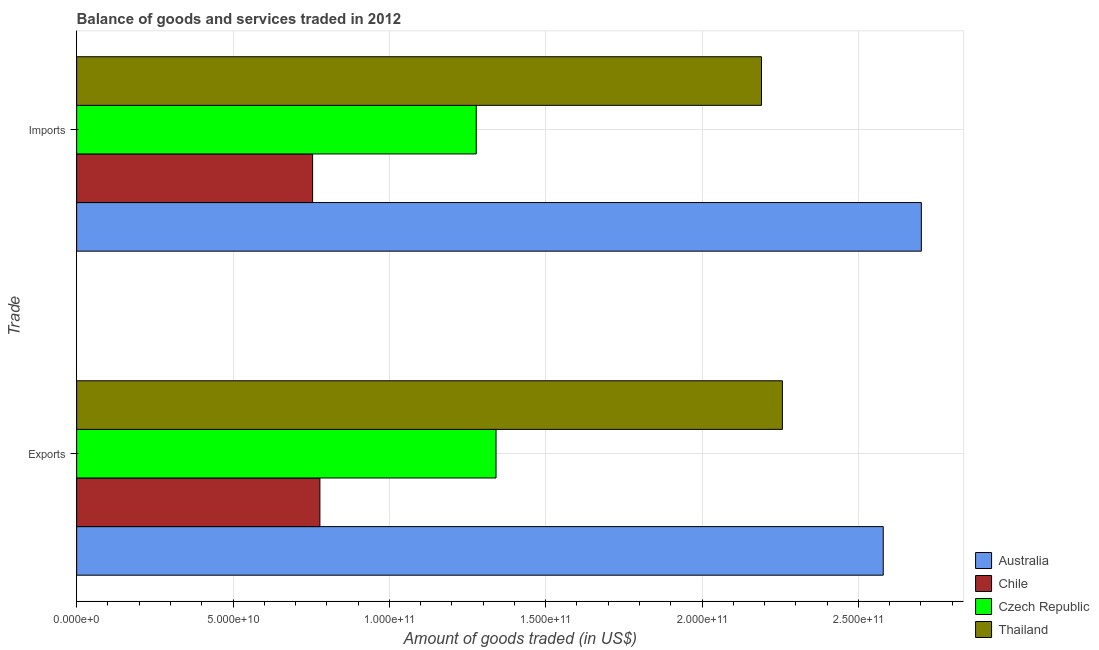How many different coloured bars are there?
Your answer should be compact. 4. How many groups of bars are there?
Offer a very short reply. 2. Are the number of bars on each tick of the Y-axis equal?
Offer a very short reply. Yes. What is the label of the 1st group of bars from the top?
Your answer should be very brief. Imports. What is the amount of goods exported in Chile?
Make the answer very short. 7.78e+1. Across all countries, what is the maximum amount of goods imported?
Your answer should be compact. 2.70e+11. Across all countries, what is the minimum amount of goods exported?
Keep it short and to the point. 7.78e+1. What is the total amount of goods exported in the graph?
Make the answer very short. 6.96e+11. What is the difference between the amount of goods exported in Australia and that in Thailand?
Your response must be concise. 3.22e+1. What is the difference between the amount of goods imported in Thailand and the amount of goods exported in Czech Republic?
Your answer should be compact. 8.49e+1. What is the average amount of goods exported per country?
Your answer should be very brief. 1.74e+11. What is the difference between the amount of goods exported and amount of goods imported in Czech Republic?
Your answer should be very brief. 6.34e+09. In how many countries, is the amount of goods exported greater than 270000000000 US$?
Make the answer very short. 0. What is the ratio of the amount of goods imported in Australia to that in Chile?
Your response must be concise. 3.58. In how many countries, is the amount of goods exported greater than the average amount of goods exported taken over all countries?
Make the answer very short. 2. What does the 4th bar from the top in Exports represents?
Offer a terse response. Australia. What does the 2nd bar from the bottom in Exports represents?
Give a very brief answer. Chile. How many bars are there?
Provide a short and direct response. 8. How many countries are there in the graph?
Offer a very short reply. 4. Does the graph contain any zero values?
Offer a terse response. No. Does the graph contain grids?
Offer a very short reply. Yes. Where does the legend appear in the graph?
Your answer should be compact. Bottom right. How many legend labels are there?
Provide a short and direct response. 4. What is the title of the graph?
Offer a very short reply. Balance of goods and services traded in 2012. What is the label or title of the X-axis?
Give a very brief answer. Amount of goods traded (in US$). What is the label or title of the Y-axis?
Offer a terse response. Trade. What is the Amount of goods traded (in US$) of Australia in Exports?
Your answer should be compact. 2.58e+11. What is the Amount of goods traded (in US$) of Chile in Exports?
Ensure brevity in your answer.  7.78e+1. What is the Amount of goods traded (in US$) in Czech Republic in Exports?
Make the answer very short. 1.34e+11. What is the Amount of goods traded (in US$) of Thailand in Exports?
Your response must be concise. 2.26e+11. What is the Amount of goods traded (in US$) in Australia in Imports?
Provide a short and direct response. 2.70e+11. What is the Amount of goods traded (in US$) in Chile in Imports?
Your response must be concise. 7.55e+1. What is the Amount of goods traded (in US$) of Czech Republic in Imports?
Give a very brief answer. 1.28e+11. What is the Amount of goods traded (in US$) in Thailand in Imports?
Keep it short and to the point. 2.19e+11. Across all Trade, what is the maximum Amount of goods traded (in US$) of Australia?
Give a very brief answer. 2.70e+11. Across all Trade, what is the maximum Amount of goods traded (in US$) in Chile?
Give a very brief answer. 7.78e+1. Across all Trade, what is the maximum Amount of goods traded (in US$) in Czech Republic?
Keep it short and to the point. 1.34e+11. Across all Trade, what is the maximum Amount of goods traded (in US$) of Thailand?
Keep it short and to the point. 2.26e+11. Across all Trade, what is the minimum Amount of goods traded (in US$) of Australia?
Your answer should be very brief. 2.58e+11. Across all Trade, what is the minimum Amount of goods traded (in US$) of Chile?
Make the answer very short. 7.55e+1. Across all Trade, what is the minimum Amount of goods traded (in US$) of Czech Republic?
Provide a succinct answer. 1.28e+11. Across all Trade, what is the minimum Amount of goods traded (in US$) in Thailand?
Your answer should be very brief. 2.19e+11. What is the total Amount of goods traded (in US$) of Australia in the graph?
Keep it short and to the point. 5.28e+11. What is the total Amount of goods traded (in US$) of Chile in the graph?
Offer a terse response. 1.53e+11. What is the total Amount of goods traded (in US$) in Czech Republic in the graph?
Provide a short and direct response. 2.62e+11. What is the total Amount of goods traded (in US$) of Thailand in the graph?
Your response must be concise. 4.45e+11. What is the difference between the Amount of goods traded (in US$) in Australia in Exports and that in Imports?
Offer a terse response. -1.22e+1. What is the difference between the Amount of goods traded (in US$) of Chile in Exports and that in Imports?
Your response must be concise. 2.33e+09. What is the difference between the Amount of goods traded (in US$) in Czech Republic in Exports and that in Imports?
Provide a short and direct response. 6.34e+09. What is the difference between the Amount of goods traded (in US$) of Thailand in Exports and that in Imports?
Offer a terse response. 6.69e+09. What is the difference between the Amount of goods traded (in US$) in Australia in Exports and the Amount of goods traded (in US$) in Chile in Imports?
Provide a succinct answer. 1.82e+11. What is the difference between the Amount of goods traded (in US$) in Australia in Exports and the Amount of goods traded (in US$) in Czech Republic in Imports?
Offer a terse response. 1.30e+11. What is the difference between the Amount of goods traded (in US$) of Australia in Exports and the Amount of goods traded (in US$) of Thailand in Imports?
Give a very brief answer. 3.89e+1. What is the difference between the Amount of goods traded (in US$) in Chile in Exports and the Amount of goods traded (in US$) in Czech Republic in Imports?
Ensure brevity in your answer.  -5.00e+1. What is the difference between the Amount of goods traded (in US$) in Chile in Exports and the Amount of goods traded (in US$) in Thailand in Imports?
Give a very brief answer. -1.41e+11. What is the difference between the Amount of goods traded (in US$) in Czech Republic in Exports and the Amount of goods traded (in US$) in Thailand in Imports?
Ensure brevity in your answer.  -8.49e+1. What is the average Amount of goods traded (in US$) in Australia per Trade?
Ensure brevity in your answer.  2.64e+11. What is the average Amount of goods traded (in US$) in Chile per Trade?
Your response must be concise. 7.66e+1. What is the average Amount of goods traded (in US$) in Czech Republic per Trade?
Provide a short and direct response. 1.31e+11. What is the average Amount of goods traded (in US$) in Thailand per Trade?
Offer a terse response. 2.22e+11. What is the difference between the Amount of goods traded (in US$) in Australia and Amount of goods traded (in US$) in Chile in Exports?
Provide a short and direct response. 1.80e+11. What is the difference between the Amount of goods traded (in US$) of Australia and Amount of goods traded (in US$) of Czech Republic in Exports?
Give a very brief answer. 1.24e+11. What is the difference between the Amount of goods traded (in US$) in Australia and Amount of goods traded (in US$) in Thailand in Exports?
Offer a terse response. 3.22e+1. What is the difference between the Amount of goods traded (in US$) in Chile and Amount of goods traded (in US$) in Czech Republic in Exports?
Ensure brevity in your answer.  -5.63e+1. What is the difference between the Amount of goods traded (in US$) of Chile and Amount of goods traded (in US$) of Thailand in Exports?
Ensure brevity in your answer.  -1.48e+11. What is the difference between the Amount of goods traded (in US$) of Czech Republic and Amount of goods traded (in US$) of Thailand in Exports?
Keep it short and to the point. -9.16e+1. What is the difference between the Amount of goods traded (in US$) of Australia and Amount of goods traded (in US$) of Chile in Imports?
Offer a terse response. 1.95e+11. What is the difference between the Amount of goods traded (in US$) in Australia and Amount of goods traded (in US$) in Czech Republic in Imports?
Offer a terse response. 1.42e+11. What is the difference between the Amount of goods traded (in US$) of Australia and Amount of goods traded (in US$) of Thailand in Imports?
Provide a short and direct response. 5.11e+1. What is the difference between the Amount of goods traded (in US$) of Chile and Amount of goods traded (in US$) of Czech Republic in Imports?
Keep it short and to the point. -5.23e+1. What is the difference between the Amount of goods traded (in US$) in Chile and Amount of goods traded (in US$) in Thailand in Imports?
Your answer should be very brief. -1.44e+11. What is the difference between the Amount of goods traded (in US$) in Czech Republic and Amount of goods traded (in US$) in Thailand in Imports?
Your answer should be compact. -9.12e+1. What is the ratio of the Amount of goods traded (in US$) of Australia in Exports to that in Imports?
Offer a very short reply. 0.95. What is the ratio of the Amount of goods traded (in US$) in Chile in Exports to that in Imports?
Offer a terse response. 1.03. What is the ratio of the Amount of goods traded (in US$) of Czech Republic in Exports to that in Imports?
Make the answer very short. 1.05. What is the ratio of the Amount of goods traded (in US$) of Thailand in Exports to that in Imports?
Ensure brevity in your answer.  1.03. What is the difference between the highest and the second highest Amount of goods traded (in US$) in Australia?
Make the answer very short. 1.22e+1. What is the difference between the highest and the second highest Amount of goods traded (in US$) in Chile?
Your response must be concise. 2.33e+09. What is the difference between the highest and the second highest Amount of goods traded (in US$) in Czech Republic?
Provide a short and direct response. 6.34e+09. What is the difference between the highest and the second highest Amount of goods traded (in US$) in Thailand?
Make the answer very short. 6.69e+09. What is the difference between the highest and the lowest Amount of goods traded (in US$) in Australia?
Your answer should be compact. 1.22e+1. What is the difference between the highest and the lowest Amount of goods traded (in US$) of Chile?
Provide a short and direct response. 2.33e+09. What is the difference between the highest and the lowest Amount of goods traded (in US$) in Czech Republic?
Your answer should be compact. 6.34e+09. What is the difference between the highest and the lowest Amount of goods traded (in US$) of Thailand?
Make the answer very short. 6.69e+09. 